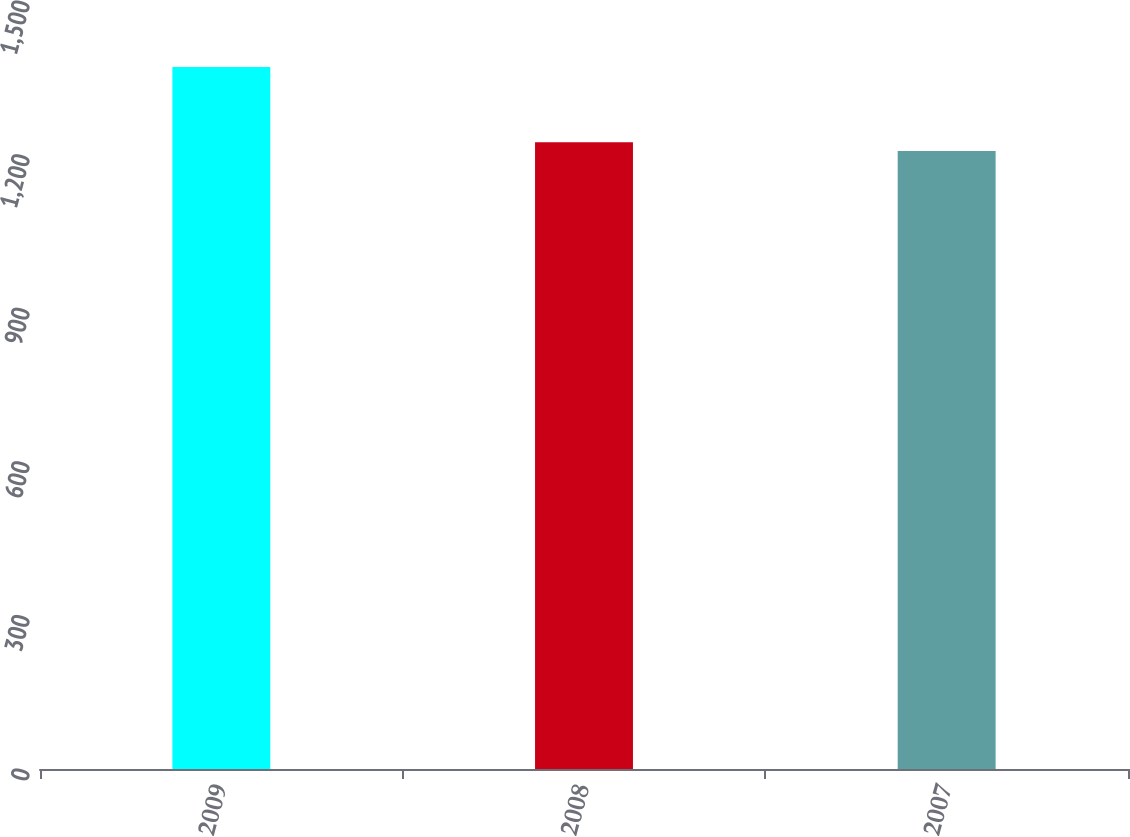<chart> <loc_0><loc_0><loc_500><loc_500><bar_chart><fcel>2009<fcel>2008<fcel>2007<nl><fcel>1371<fcel>1224<fcel>1207<nl></chart> 